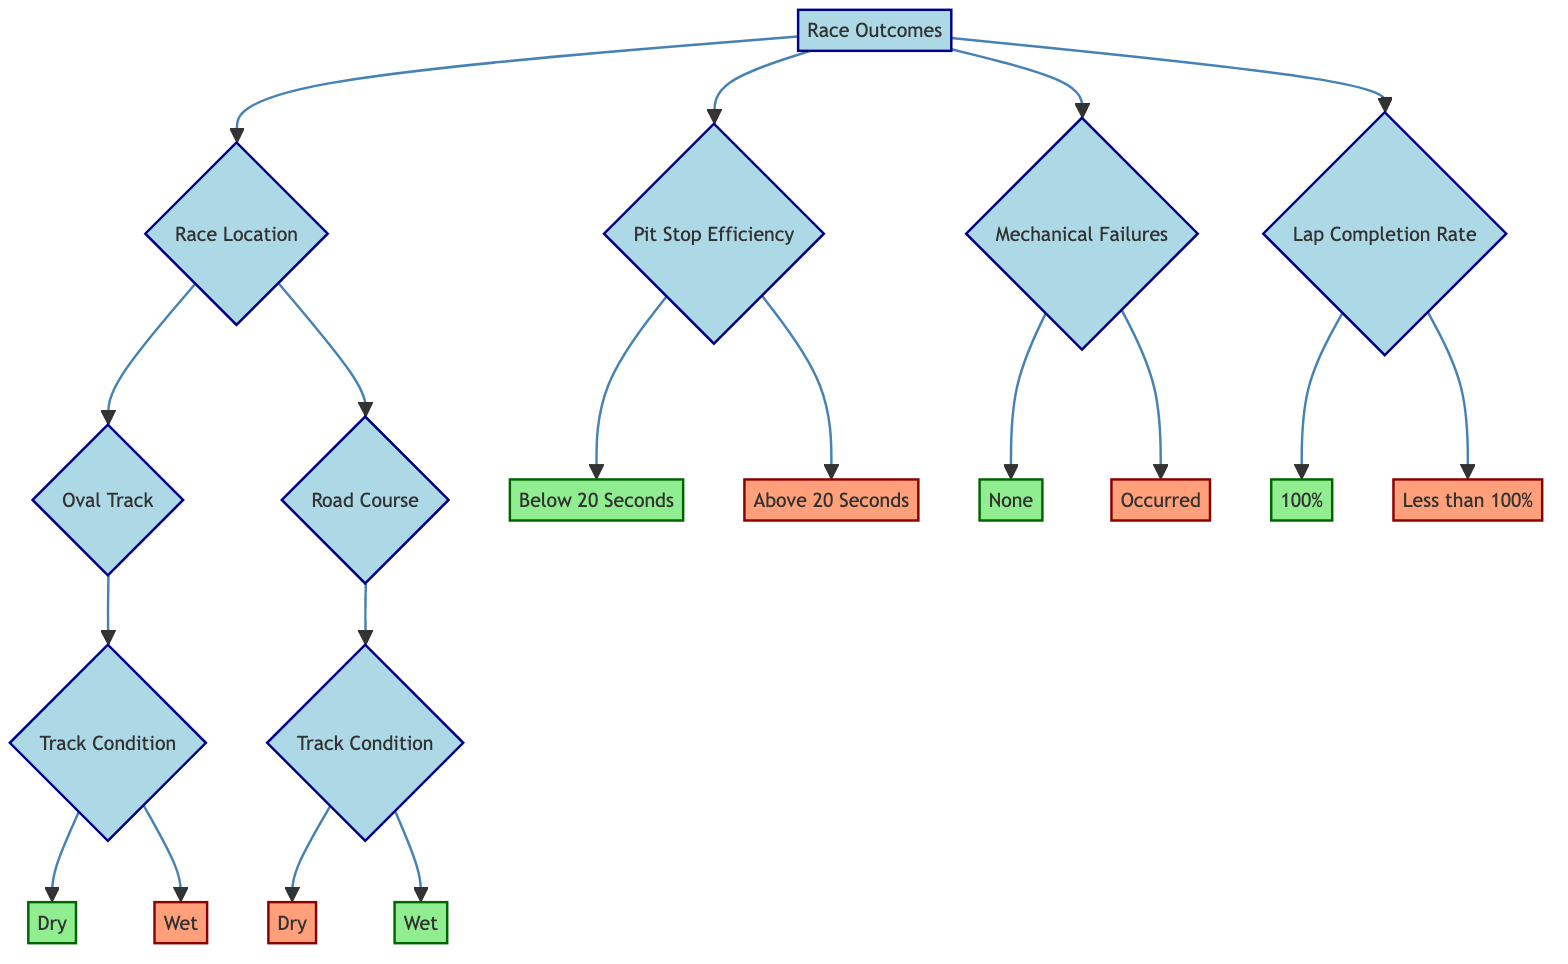What is the result when the race location is an Oval Track and the track condition is Dry? According to the diagram, when the race location is an Oval Track, the next node checks the Track Condition. If the Track Condition is Dry, it leads to a Win.
Answer: Win What happens if the race location is a Road Course and the track condition is Wet? The diagram shows that if the race location is a Road Course and the track condition is Wet, it results in a Win.
Answer: Win How many main factors are leading to race outcomes? The diagram lists four main factors under Race Outcomes: Race Location, Pit Stop Efficiency, Mechanical Failures, and Lap Completion Rate, resulting in a total of four factors.
Answer: Four What is the result for a Lap Completion Rate of less than 100%? According to the diagram, if the Lap Completion Rate is Less than 100%, it leads to a Loss.
Answer: Loss What does a Pit Stop Efficiency below 20 seconds lead to? The diagram indicates that a Pit Stop Efficiency of Below 20 Seconds results in a Win.
Answer: Win If there are Mechanical Failures, what is the outcome? The diagram states that if Mechanical Failures Occurred, the outcome is a Loss.
Answer: Loss Which outcome results from a race with a Track Condition of Wet on an Oval Track? The diagram specifies that when the track condition is Wet on an Oval Track, the result is a Loss.
Answer: Loss What is the result when the Lap Completion Rate is 100%? Based on the diagram, a Lap Completion Rate of 100% leads to a Win.
Answer: Win What type of track condition is necessary for winning on a Road Course? The diagram indicates that the track condition must be Wet to achieve a Win on a Road Course.
Answer: Wet 